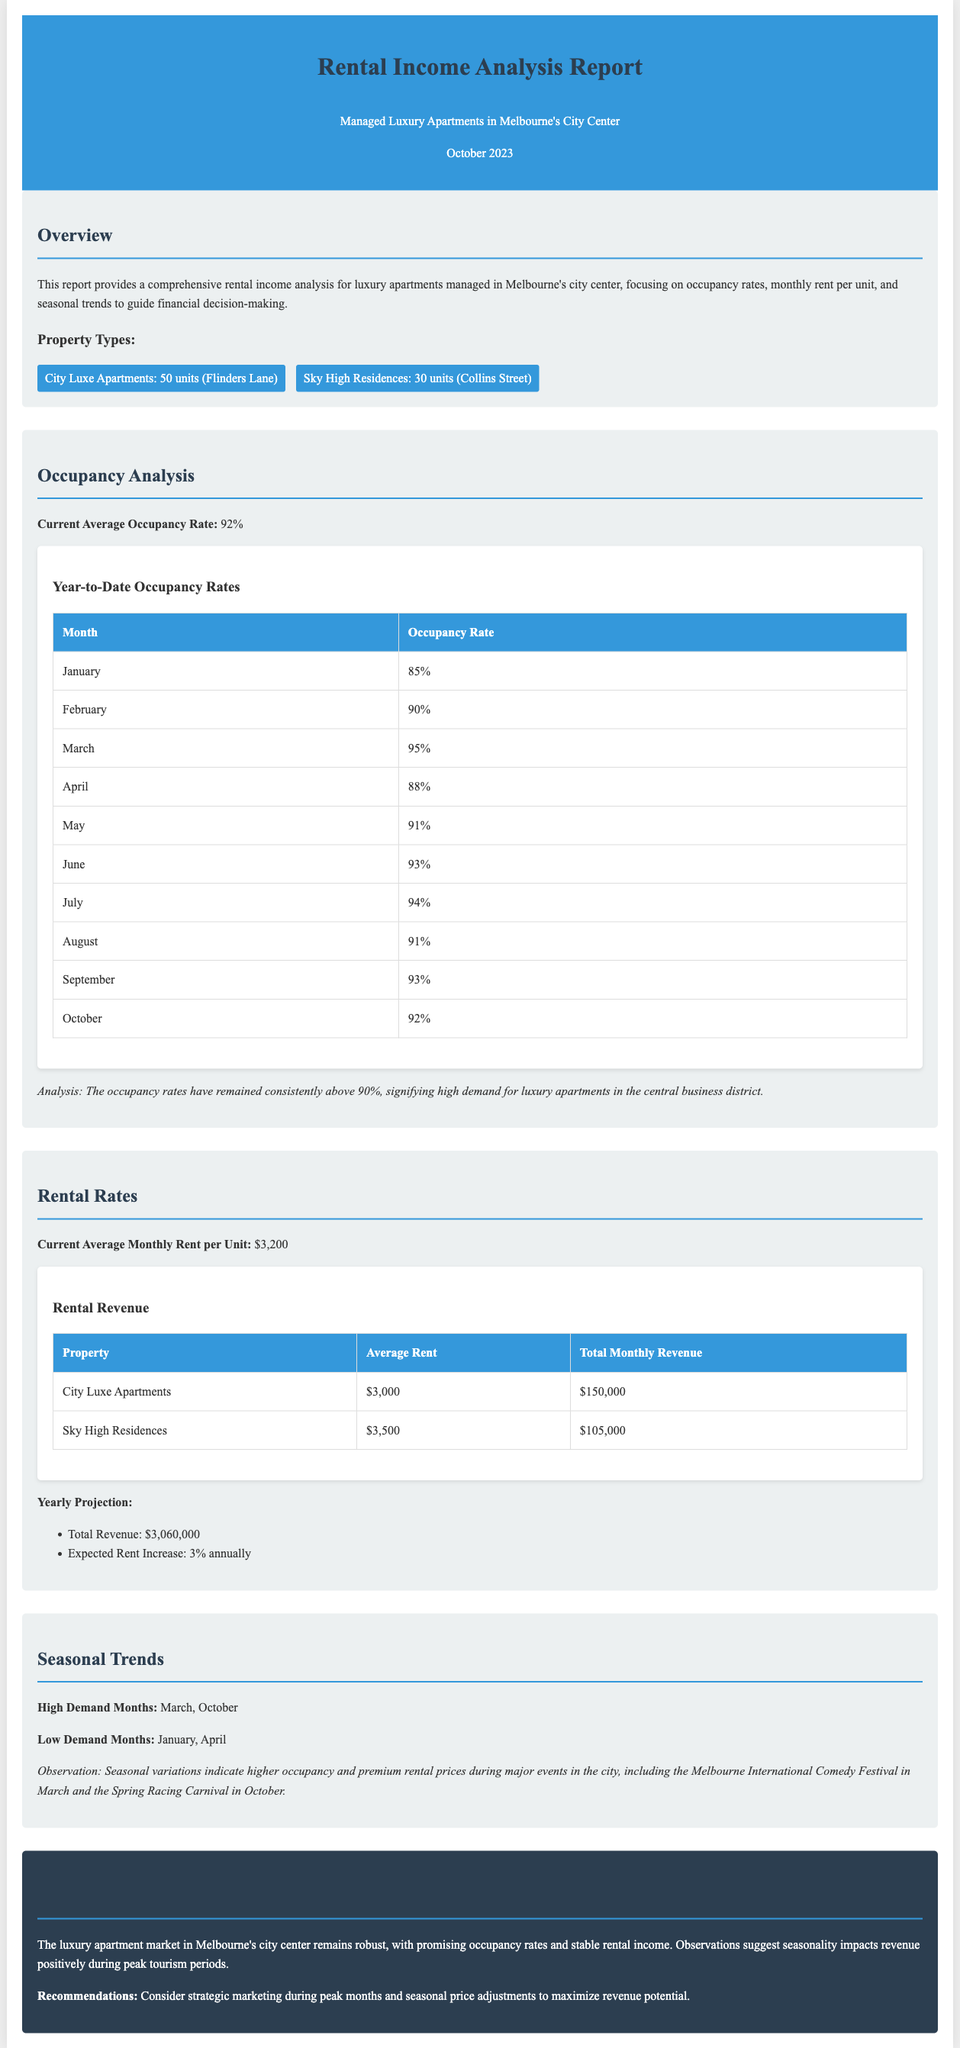What is the current average occupancy rate? The current average occupancy rate is a key figure mentioned in the occupancy analysis section of the report.
Answer: 92% What is the average monthly rent per unit? This information is provided in the rental rates section where the average monthly rent is specifically mentioned.
Answer: $3,200 Which month has the highest occupancy rate? This can be inferred from the year-to-date occupancy rates table, highlighting the month with the peak value.
Answer: March What is the total monthly revenue for City Luxe Apartments? The total monthly revenue can be found in the rental revenue table under the City Luxe Apartments row.
Answer: $150,000 What are the low demand months according to the seasonal trends? The report explicitly states these months in the seasonal trends section, summarizing the periods with less demand.
Answer: January, April What is the expected rent increase per year? The yearly projection section indicates this as part of the financial outlook for rental income.
Answer: 3% What is the total revenue projection for the year? This figure can also be found in the yearly projection section and represents the anticipated income from rentals for the full year.
Answer: $3,060,000 What property type has the highest average rent? The average rents table allows for a direct comparison between the two property types to identify which has the higher value.
Answer: Sky High Residences What event is associated with high demand in March? The seasonal trends section highlights significant events that correlate with increased demand during specific months.
Answer: Melbourne International Comedy Festival 